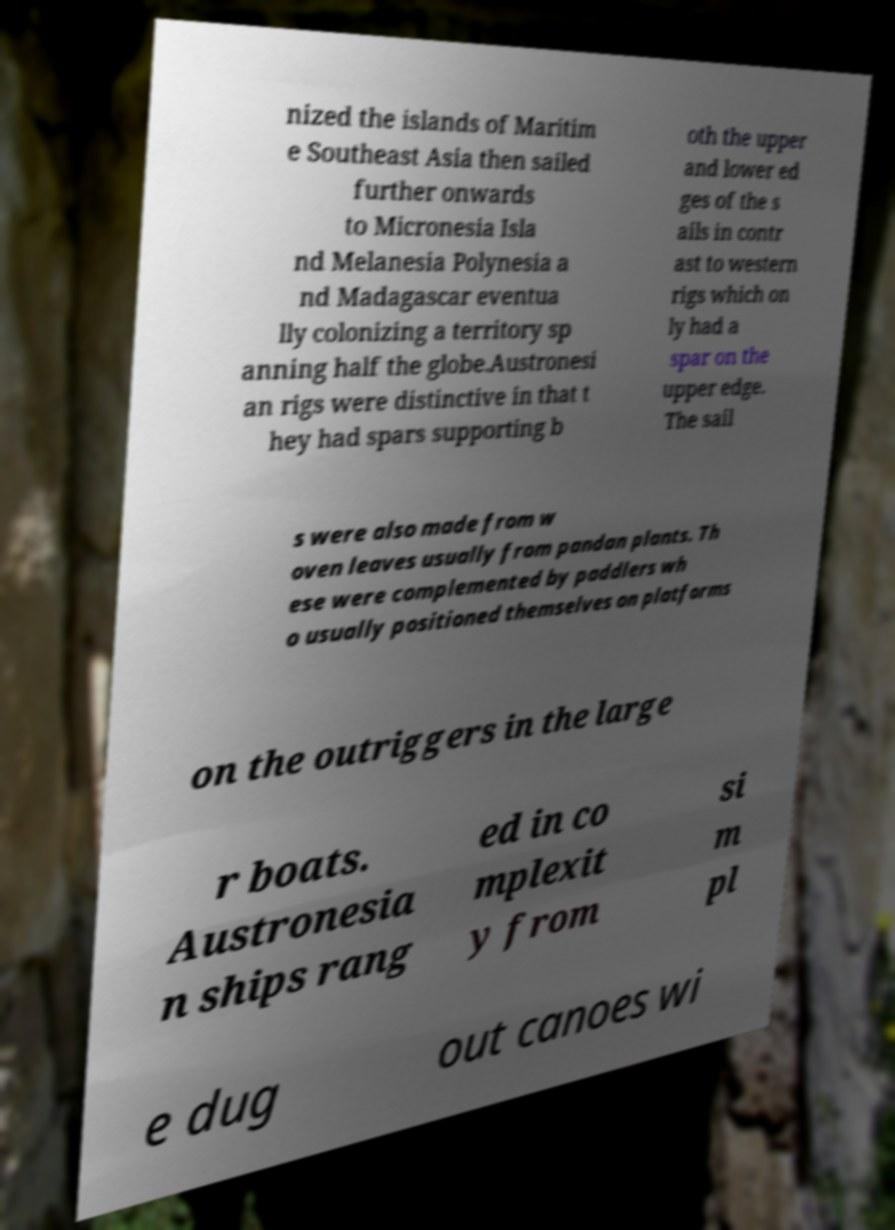There's text embedded in this image that I need extracted. Can you transcribe it verbatim? nized the islands of Maritim e Southeast Asia then sailed further onwards to Micronesia Isla nd Melanesia Polynesia a nd Madagascar eventua lly colonizing a territory sp anning half the globe.Austronesi an rigs were distinctive in that t hey had spars supporting b oth the upper and lower ed ges of the s ails in contr ast to western rigs which on ly had a spar on the upper edge. The sail s were also made from w oven leaves usually from pandan plants. Th ese were complemented by paddlers wh o usually positioned themselves on platforms on the outriggers in the large r boats. Austronesia n ships rang ed in co mplexit y from si m pl e dug out canoes wi 